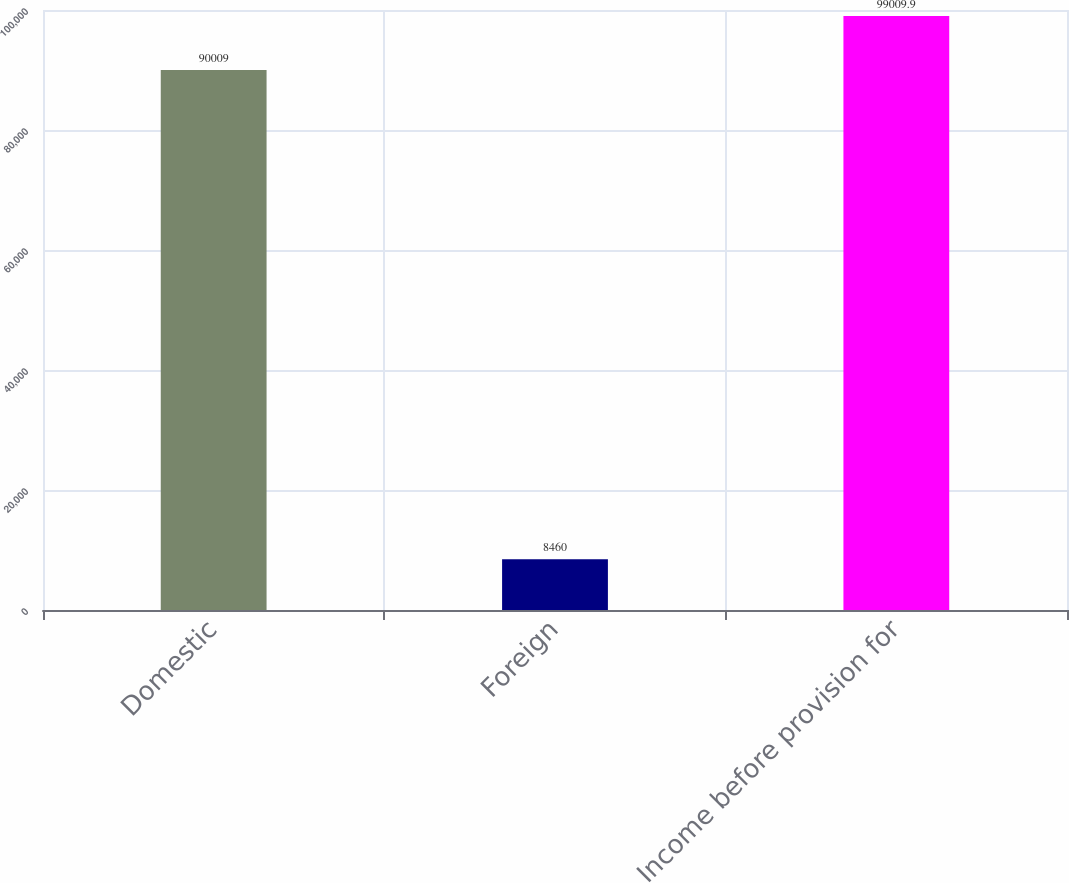Convert chart. <chart><loc_0><loc_0><loc_500><loc_500><bar_chart><fcel>Domestic<fcel>Foreign<fcel>Income before provision for<nl><fcel>90009<fcel>8460<fcel>99009.9<nl></chart> 